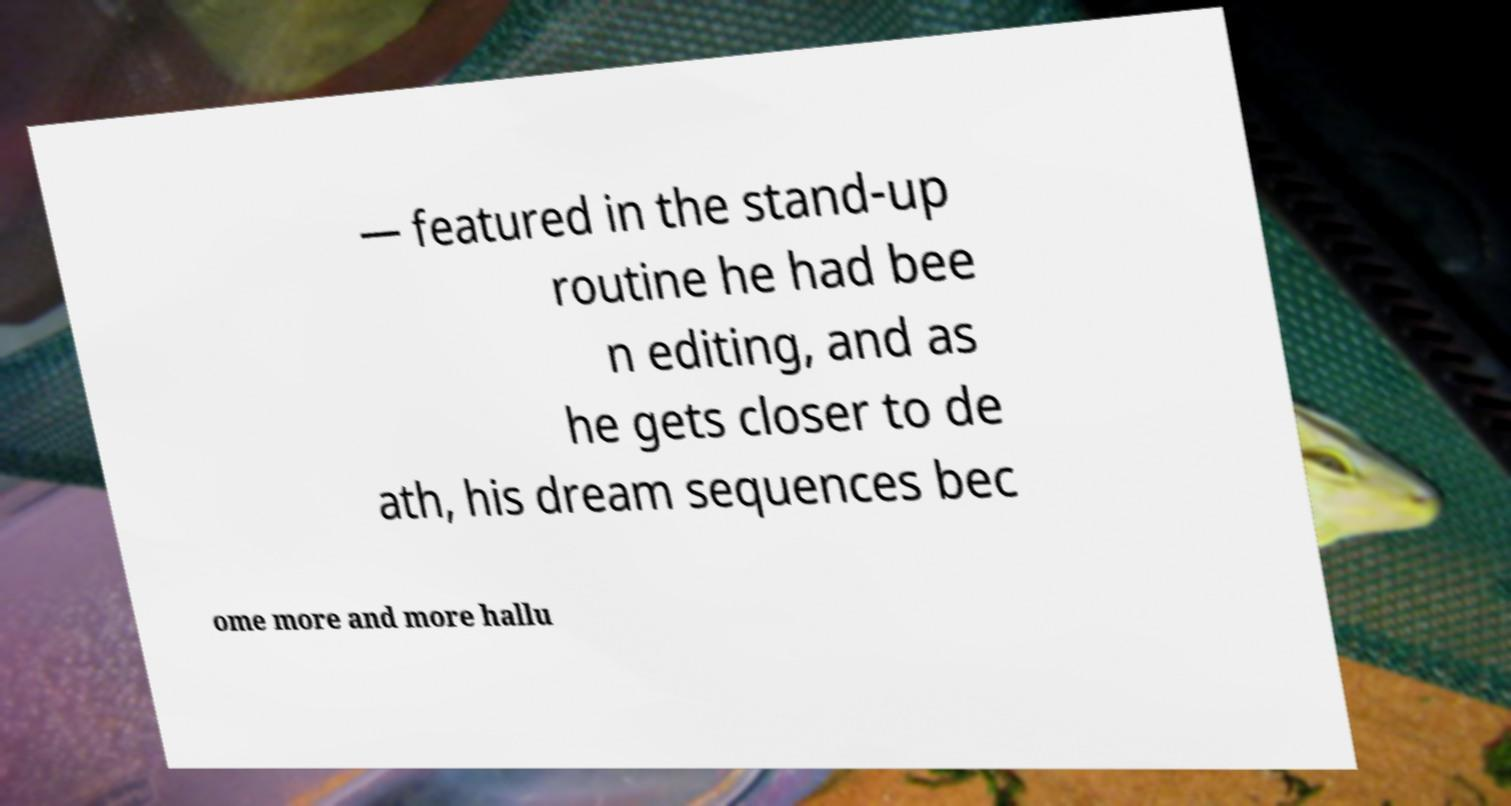What messages or text are displayed in this image? I need them in a readable, typed format. — featured in the stand-up routine he had bee n editing, and as he gets closer to de ath, his dream sequences bec ome more and more hallu 